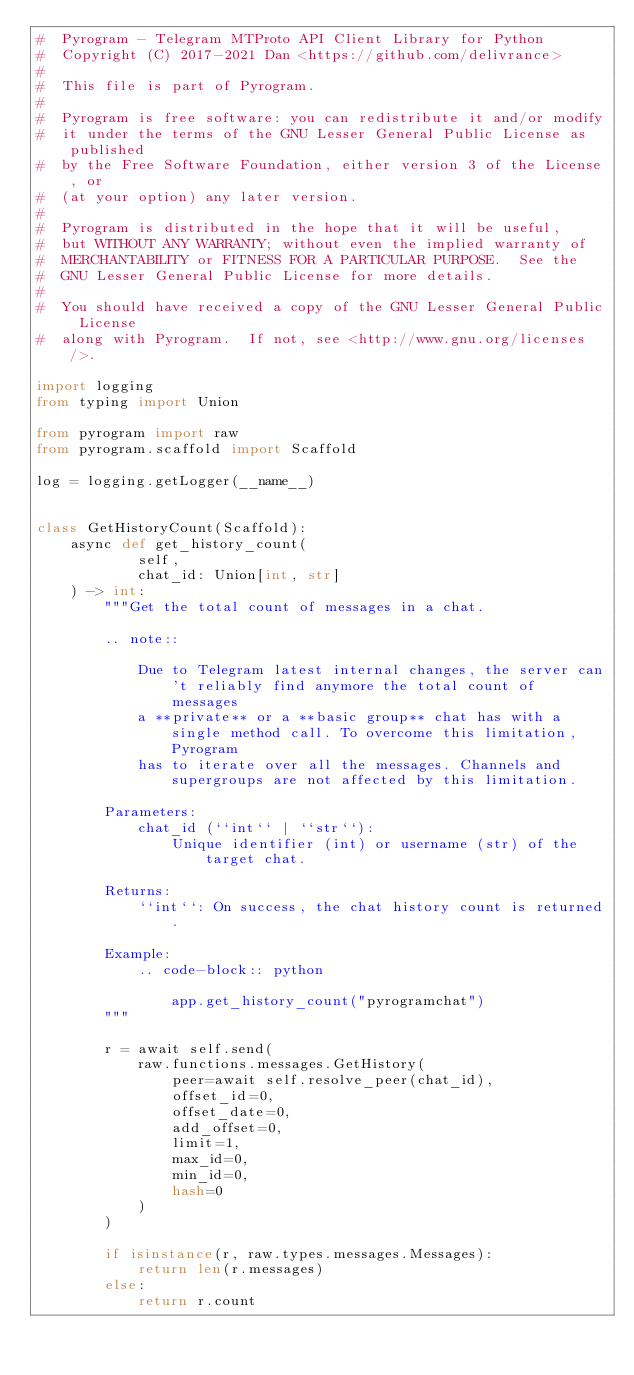Convert code to text. <code><loc_0><loc_0><loc_500><loc_500><_Python_>#  Pyrogram - Telegram MTProto API Client Library for Python
#  Copyright (C) 2017-2021 Dan <https://github.com/delivrance>
#
#  This file is part of Pyrogram.
#
#  Pyrogram is free software: you can redistribute it and/or modify
#  it under the terms of the GNU Lesser General Public License as published
#  by the Free Software Foundation, either version 3 of the License, or
#  (at your option) any later version.
#
#  Pyrogram is distributed in the hope that it will be useful,
#  but WITHOUT ANY WARRANTY; without even the implied warranty of
#  MERCHANTABILITY or FITNESS FOR A PARTICULAR PURPOSE.  See the
#  GNU Lesser General Public License for more details.
#
#  You should have received a copy of the GNU Lesser General Public License
#  along with Pyrogram.  If not, see <http://www.gnu.org/licenses/>.

import logging
from typing import Union

from pyrogram import raw
from pyrogram.scaffold import Scaffold

log = logging.getLogger(__name__)


class GetHistoryCount(Scaffold):
    async def get_history_count(
            self,
            chat_id: Union[int, str]
    ) -> int:
        """Get the total count of messages in a chat.

        .. note::

            Due to Telegram latest internal changes, the server can't reliably find anymore the total count of messages
            a **private** or a **basic group** chat has with a single method call. To overcome this limitation, Pyrogram
            has to iterate over all the messages. Channels and supergroups are not affected by this limitation.

        Parameters:
            chat_id (``int`` | ``str``):
                Unique identifier (int) or username (str) of the target chat.

        Returns:
            ``int``: On success, the chat history count is returned.

        Example:
            .. code-block:: python

                app.get_history_count("pyrogramchat")
        """

        r = await self.send(
            raw.functions.messages.GetHistory(
                peer=await self.resolve_peer(chat_id),
                offset_id=0,
                offset_date=0,
                add_offset=0,
                limit=1,
                max_id=0,
                min_id=0,
                hash=0
            )
        )

        if isinstance(r, raw.types.messages.Messages):
            return len(r.messages)
        else:
            return r.count
</code> 